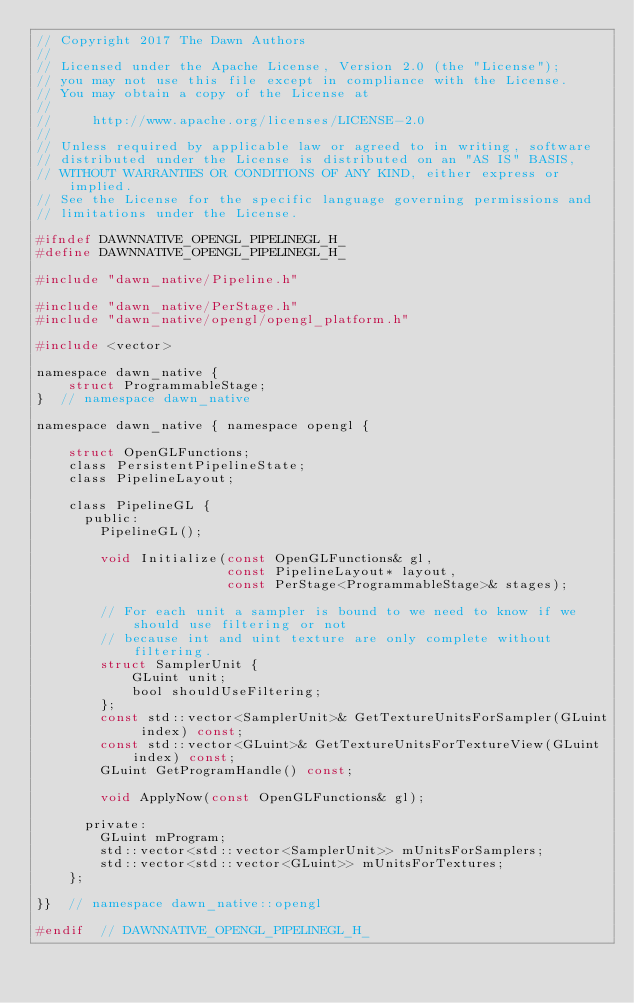Convert code to text. <code><loc_0><loc_0><loc_500><loc_500><_C_>// Copyright 2017 The Dawn Authors
//
// Licensed under the Apache License, Version 2.0 (the "License");
// you may not use this file except in compliance with the License.
// You may obtain a copy of the License at
//
//     http://www.apache.org/licenses/LICENSE-2.0
//
// Unless required by applicable law or agreed to in writing, software
// distributed under the License is distributed on an "AS IS" BASIS,
// WITHOUT WARRANTIES OR CONDITIONS OF ANY KIND, either express or implied.
// See the License for the specific language governing permissions and
// limitations under the License.

#ifndef DAWNNATIVE_OPENGL_PIPELINEGL_H_
#define DAWNNATIVE_OPENGL_PIPELINEGL_H_

#include "dawn_native/Pipeline.h"

#include "dawn_native/PerStage.h"
#include "dawn_native/opengl/opengl_platform.h"

#include <vector>

namespace dawn_native {
    struct ProgrammableStage;
}  // namespace dawn_native

namespace dawn_native { namespace opengl {

    struct OpenGLFunctions;
    class PersistentPipelineState;
    class PipelineLayout;

    class PipelineGL {
      public:
        PipelineGL();

        void Initialize(const OpenGLFunctions& gl,
                        const PipelineLayout* layout,
                        const PerStage<ProgrammableStage>& stages);

        // For each unit a sampler is bound to we need to know if we should use filtering or not
        // because int and uint texture are only complete without filtering.
        struct SamplerUnit {
            GLuint unit;
            bool shouldUseFiltering;
        };
        const std::vector<SamplerUnit>& GetTextureUnitsForSampler(GLuint index) const;
        const std::vector<GLuint>& GetTextureUnitsForTextureView(GLuint index) const;
        GLuint GetProgramHandle() const;

        void ApplyNow(const OpenGLFunctions& gl);

      private:
        GLuint mProgram;
        std::vector<std::vector<SamplerUnit>> mUnitsForSamplers;
        std::vector<std::vector<GLuint>> mUnitsForTextures;
    };

}}  // namespace dawn_native::opengl

#endif  // DAWNNATIVE_OPENGL_PIPELINEGL_H_
</code> 